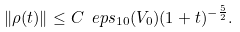Convert formula to latex. <formula><loc_0><loc_0><loc_500><loc_500>\| \rho ( t ) \| \leq C \ e p s _ { 1 0 } ( V _ { 0 } ) ( 1 + t ) ^ { - \frac { 5 } { 2 } } .</formula> 